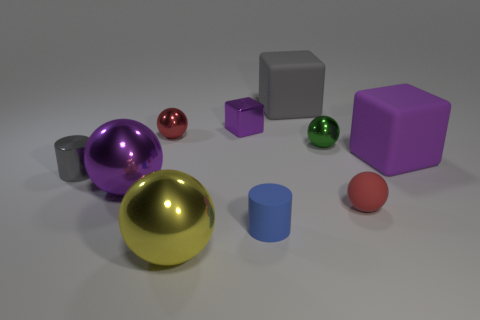Subtract all purple cubes. How many cubes are left? 1 Subtract all gray cylinders. How many cylinders are left? 1 Subtract 3 cubes. How many cubes are left? 0 Subtract all blue cylinders. Subtract all green blocks. How many cylinders are left? 1 Subtract all blue blocks. How many gray cylinders are left? 1 Subtract all small brown matte objects. Subtract all purple metallic blocks. How many objects are left? 9 Add 8 purple spheres. How many purple spheres are left? 9 Add 8 small brown shiny cubes. How many small brown shiny cubes exist? 8 Subtract 0 yellow cylinders. How many objects are left? 10 Subtract all blocks. How many objects are left? 7 